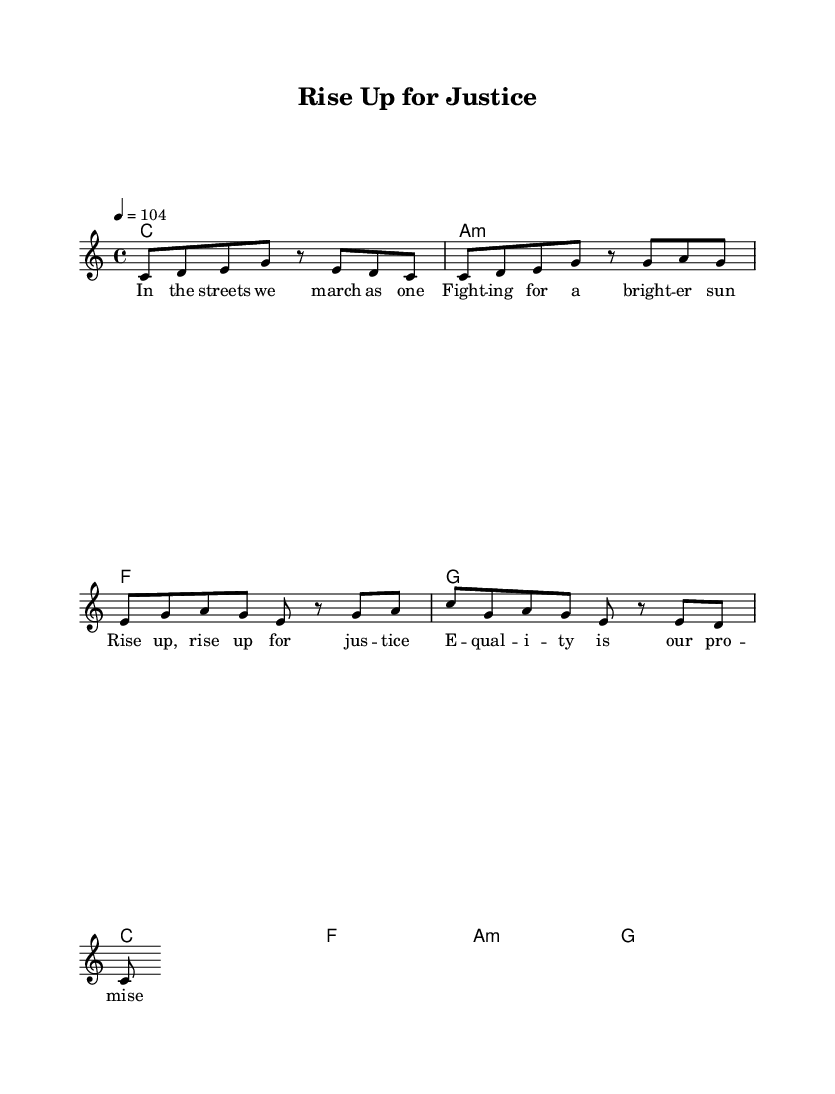What is the key signature of this music? The key signature is indicated at the beginning of the sheet music, showing no sharps or flats, which denotes the key of C major.
Answer: C major What is the time signature of this piece? The time signature is represented by the fraction at the beginning of the music, which shows 4 beats per measure with each beat being a quarter note.
Answer: 4/4 What is the tempo marking for this piece? The tempo marking is also found at the beginning, indicating a tempo of 104 beats per minute.
Answer: 104 How many measures are there in the verse? Counting the measures in the verse section reveals a total of 4 measures indicated by the vertical lines in the music.
Answer: 4 What is the first lyric line in the chorus? The first line of lyrics appears underneath the music for the chorus section, stating "Rise up, rise up for justice."
Answer: Rise up, rise up for justice What genre does this piece belong to based on its characteristics? The rhythmic pattern, instrumentation, and lyrical themes of social justice suggest it is characteristic of the reggae genre.
Answer: Reggae How do the chord progressions in the chorus compare to those in the verse? The chord progression for the chorus consists of C, F, Am, and G, which are mostly parallel to the ones in the verse, yet transitions them to match the lyrical emphasis on social themes.
Answer: Parallel 